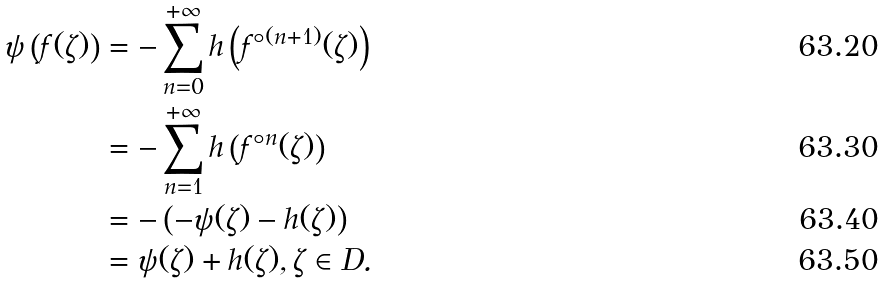<formula> <loc_0><loc_0><loc_500><loc_500>\psi \left ( f ( \zeta ) \right ) & = - \sum _ { n = 0 } ^ { + \infty } h \left ( f ^ { \circ ( n + 1 ) } ( \zeta ) \right ) \\ & = - \sum _ { n = 1 } ^ { + \infty } h \left ( f ^ { \circ n } ( \zeta ) \right ) \\ & = - \left ( - \psi ( \zeta ) - h ( \zeta ) \right ) \\ & = \psi ( \zeta ) + h ( \zeta ) , \zeta \in D .</formula> 